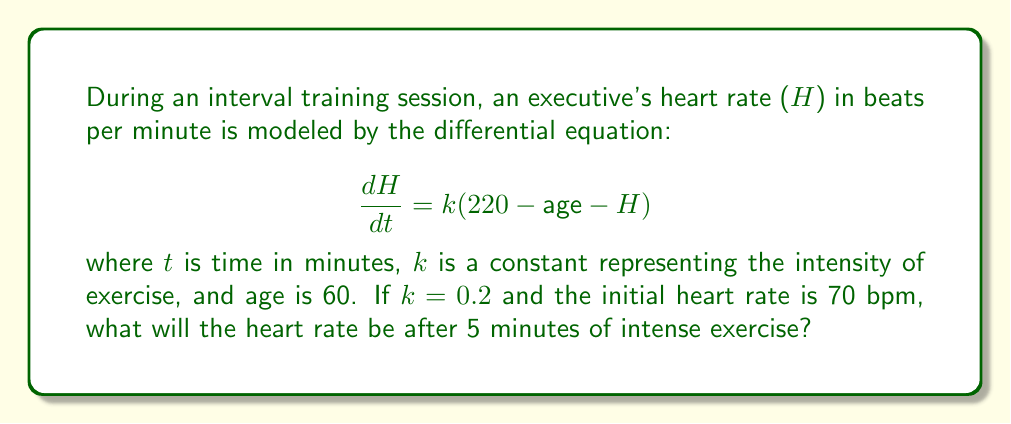Solve this math problem. To solve this problem, we need to follow these steps:

1) First, let's substitute the given values into our differential equation:
   $$\frac{dH}{dt} = 0.2(220 - 60 - H) = 0.2(160 - H)$$

2) This is a separable differential equation. Let's rearrange it:
   $$\frac{dH}{160 - H} = 0.2dt$$

3) Integrate both sides:
   $$\int \frac{dH}{160 - H} = \int 0.2dt$$

4) The left side integrates to $-\ln|160 - H|$, and the right side to $0.2t + C$:
   $$-\ln|160 - H| = 0.2t + C$$

5) Solve for H:
   $$\ln|160 - H| = -0.2t - C$$
   $$160 - H = e^{-0.2t - C} = Ae^{-0.2t}$$ where $A = e^{-C}$
   $$H = 160 - Ae^{-0.2t}$$

6) Use the initial condition (H = 70 when t = 0) to find A:
   $$70 = 160 - A$$
   $$A = 90$$

7) So our solution is:
   $$H = 160 - 90e^{-0.2t}$$

8) To find H when t = 5, we substitute t = 5:
   $$H = 160 - 90e^{-0.2(5)} \approx 131.7$$

Therefore, after 5 minutes of intense exercise, the heart rate will be approximately 132 bpm.
Answer: 132 bpm 